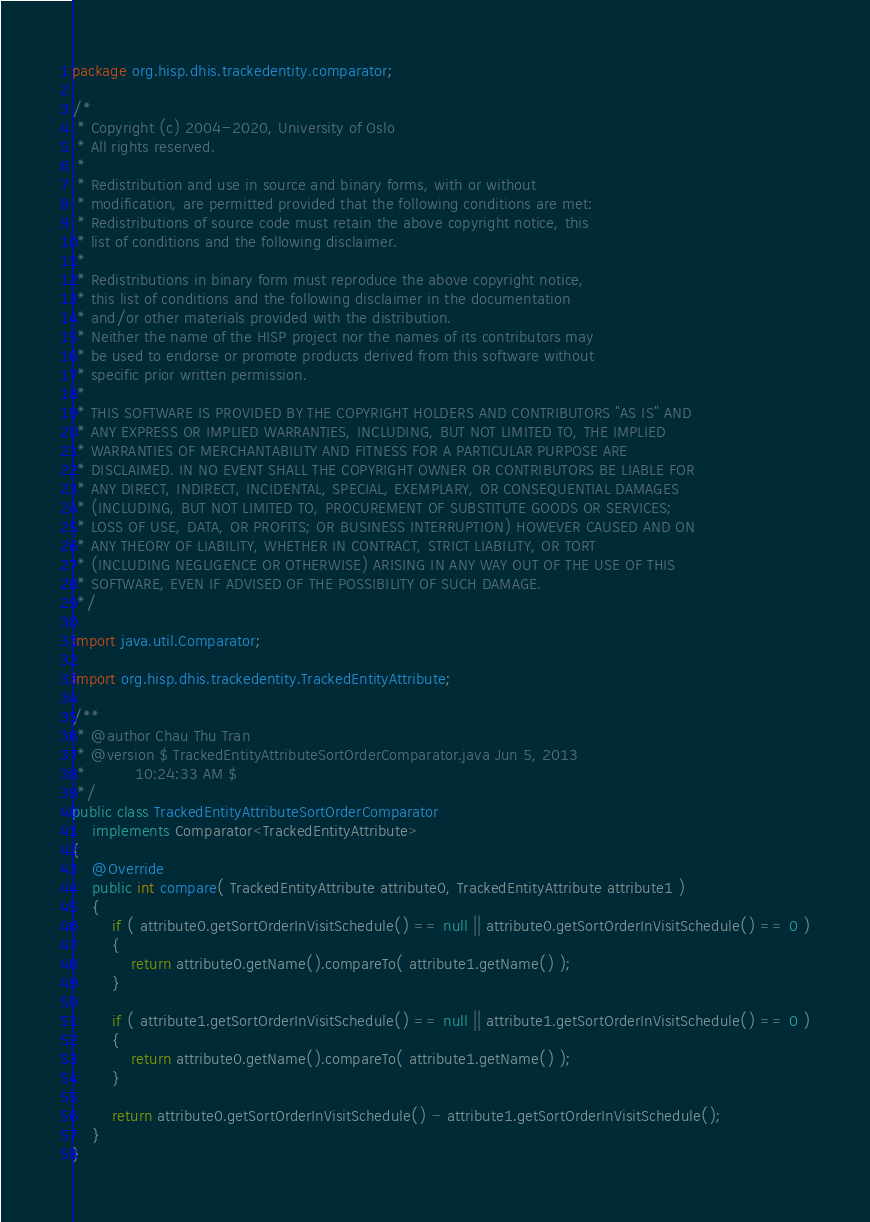Convert code to text. <code><loc_0><loc_0><loc_500><loc_500><_Java_>package org.hisp.dhis.trackedentity.comparator;

/*
 * Copyright (c) 2004-2020, University of Oslo
 * All rights reserved.
 *
 * Redistribution and use in source and binary forms, with or without
 * modification, are permitted provided that the following conditions are met:
 * Redistributions of source code must retain the above copyright notice, this
 * list of conditions and the following disclaimer.
 *
 * Redistributions in binary form must reproduce the above copyright notice,
 * this list of conditions and the following disclaimer in the documentation
 * and/or other materials provided with the distribution.
 * Neither the name of the HISP project nor the names of its contributors may
 * be used to endorse or promote products derived from this software without
 * specific prior written permission.
 *
 * THIS SOFTWARE IS PROVIDED BY THE COPYRIGHT HOLDERS AND CONTRIBUTORS "AS IS" AND
 * ANY EXPRESS OR IMPLIED WARRANTIES, INCLUDING, BUT NOT LIMITED TO, THE IMPLIED
 * WARRANTIES OF MERCHANTABILITY AND FITNESS FOR A PARTICULAR PURPOSE ARE
 * DISCLAIMED. IN NO EVENT SHALL THE COPYRIGHT OWNER OR CONTRIBUTORS BE LIABLE FOR
 * ANY DIRECT, INDIRECT, INCIDENTAL, SPECIAL, EXEMPLARY, OR CONSEQUENTIAL DAMAGES
 * (INCLUDING, BUT NOT LIMITED TO, PROCUREMENT OF SUBSTITUTE GOODS OR SERVICES;
 * LOSS OF USE, DATA, OR PROFITS; OR BUSINESS INTERRUPTION) HOWEVER CAUSED AND ON
 * ANY THEORY OF LIABILITY, WHETHER IN CONTRACT, STRICT LIABILITY, OR TORT
 * (INCLUDING NEGLIGENCE OR OTHERWISE) ARISING IN ANY WAY OUT OF THE USE OF THIS
 * SOFTWARE, EVEN IF ADVISED OF THE POSSIBILITY OF SUCH DAMAGE.
 */

import java.util.Comparator;

import org.hisp.dhis.trackedentity.TrackedEntityAttribute;

/**
 * @author Chau Thu Tran
 * @version $ TrackedEntityAttributeSortOrderComparator.java Jun 5, 2013
 *          10:24:33 AM $
 */
public class TrackedEntityAttributeSortOrderComparator
    implements Comparator<TrackedEntityAttribute>
{
    @Override
    public int compare( TrackedEntityAttribute attribute0, TrackedEntityAttribute attribute1 )
    {
        if ( attribute0.getSortOrderInVisitSchedule() == null || attribute0.getSortOrderInVisitSchedule() == 0 )
        {
            return attribute0.getName().compareTo( attribute1.getName() );
        }

        if ( attribute1.getSortOrderInVisitSchedule() == null || attribute1.getSortOrderInVisitSchedule() == 0 )
        {
            return attribute0.getName().compareTo( attribute1.getName() );
        }

        return attribute0.getSortOrderInVisitSchedule() - attribute1.getSortOrderInVisitSchedule();
    }
}
</code> 